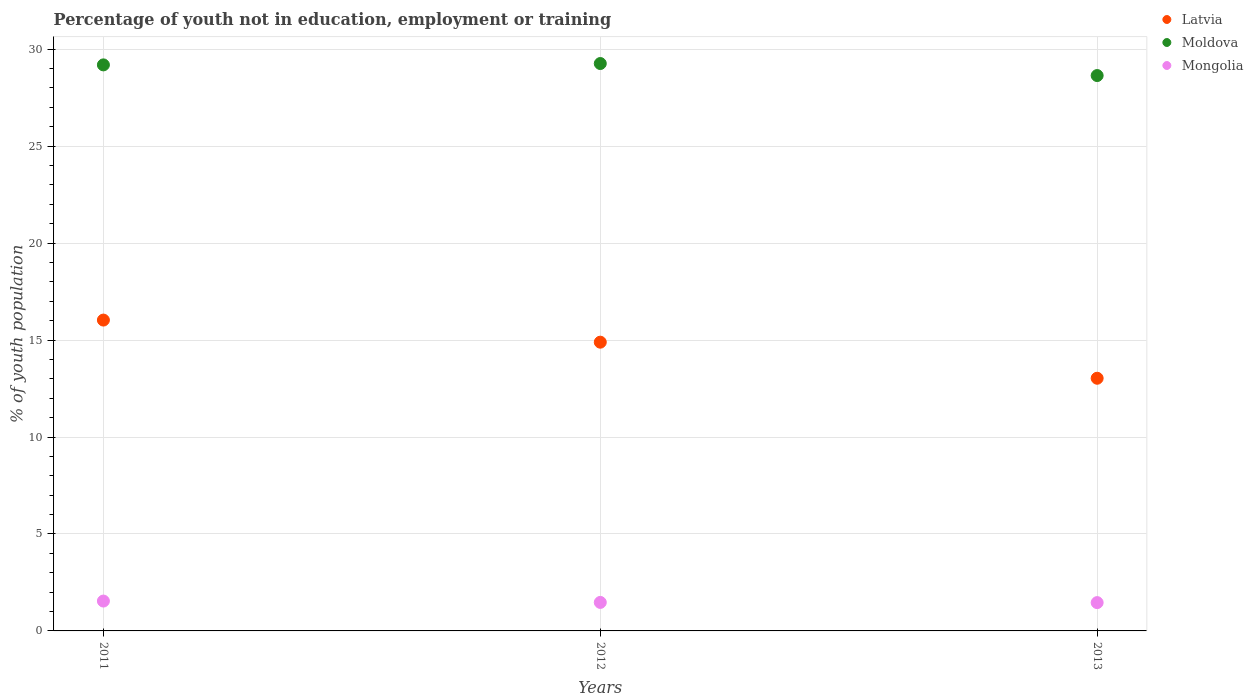How many different coloured dotlines are there?
Make the answer very short. 3. Is the number of dotlines equal to the number of legend labels?
Offer a terse response. Yes. What is the percentage of unemployed youth population in in Moldova in 2013?
Provide a succinct answer. 28.64. Across all years, what is the maximum percentage of unemployed youth population in in Latvia?
Offer a very short reply. 16.03. Across all years, what is the minimum percentage of unemployed youth population in in Mongolia?
Provide a short and direct response. 1.46. In which year was the percentage of unemployed youth population in in Latvia minimum?
Your answer should be very brief. 2013. What is the total percentage of unemployed youth population in in Latvia in the graph?
Your answer should be very brief. 43.95. What is the difference between the percentage of unemployed youth population in in Latvia in 2011 and that in 2013?
Your answer should be very brief. 3. What is the difference between the percentage of unemployed youth population in in Mongolia in 2013 and the percentage of unemployed youth population in in Moldova in 2012?
Your answer should be compact. -27.8. What is the average percentage of unemployed youth population in in Mongolia per year?
Your answer should be compact. 1.49. In the year 2012, what is the difference between the percentage of unemployed youth population in in Latvia and percentage of unemployed youth population in in Mongolia?
Provide a short and direct response. 13.42. What is the ratio of the percentage of unemployed youth population in in Latvia in 2011 to that in 2012?
Your answer should be compact. 1.08. Is the percentage of unemployed youth population in in Mongolia in 2011 less than that in 2013?
Ensure brevity in your answer.  No. What is the difference between the highest and the second highest percentage of unemployed youth population in in Latvia?
Provide a succinct answer. 1.14. What is the difference between the highest and the lowest percentage of unemployed youth population in in Latvia?
Make the answer very short. 3. Does the percentage of unemployed youth population in in Mongolia monotonically increase over the years?
Give a very brief answer. No. Is the percentage of unemployed youth population in in Latvia strictly greater than the percentage of unemployed youth population in in Mongolia over the years?
Offer a terse response. Yes. Is the percentage of unemployed youth population in in Mongolia strictly less than the percentage of unemployed youth population in in Moldova over the years?
Ensure brevity in your answer.  Yes. What is the difference between two consecutive major ticks on the Y-axis?
Keep it short and to the point. 5. Are the values on the major ticks of Y-axis written in scientific E-notation?
Your response must be concise. No. Does the graph contain any zero values?
Keep it short and to the point. No. Where does the legend appear in the graph?
Offer a terse response. Top right. What is the title of the graph?
Make the answer very short. Percentage of youth not in education, employment or training. Does "New Zealand" appear as one of the legend labels in the graph?
Ensure brevity in your answer.  No. What is the label or title of the Y-axis?
Give a very brief answer. % of youth population. What is the % of youth population of Latvia in 2011?
Ensure brevity in your answer.  16.03. What is the % of youth population in Moldova in 2011?
Ensure brevity in your answer.  29.19. What is the % of youth population in Mongolia in 2011?
Your answer should be compact. 1.54. What is the % of youth population in Latvia in 2012?
Your answer should be very brief. 14.89. What is the % of youth population of Moldova in 2012?
Keep it short and to the point. 29.26. What is the % of youth population of Mongolia in 2012?
Your response must be concise. 1.47. What is the % of youth population in Latvia in 2013?
Your answer should be very brief. 13.03. What is the % of youth population in Moldova in 2013?
Offer a terse response. 28.64. What is the % of youth population in Mongolia in 2013?
Ensure brevity in your answer.  1.46. Across all years, what is the maximum % of youth population of Latvia?
Make the answer very short. 16.03. Across all years, what is the maximum % of youth population in Moldova?
Offer a very short reply. 29.26. Across all years, what is the maximum % of youth population of Mongolia?
Give a very brief answer. 1.54. Across all years, what is the minimum % of youth population in Latvia?
Offer a very short reply. 13.03. Across all years, what is the minimum % of youth population in Moldova?
Offer a terse response. 28.64. Across all years, what is the minimum % of youth population of Mongolia?
Your answer should be compact. 1.46. What is the total % of youth population in Latvia in the graph?
Ensure brevity in your answer.  43.95. What is the total % of youth population in Moldova in the graph?
Ensure brevity in your answer.  87.09. What is the total % of youth population in Mongolia in the graph?
Your response must be concise. 4.47. What is the difference between the % of youth population in Latvia in 2011 and that in 2012?
Your answer should be very brief. 1.14. What is the difference between the % of youth population of Moldova in 2011 and that in 2012?
Provide a short and direct response. -0.07. What is the difference between the % of youth population of Mongolia in 2011 and that in 2012?
Offer a terse response. 0.07. What is the difference between the % of youth population of Latvia in 2011 and that in 2013?
Your answer should be very brief. 3. What is the difference between the % of youth population of Moldova in 2011 and that in 2013?
Provide a short and direct response. 0.55. What is the difference between the % of youth population of Mongolia in 2011 and that in 2013?
Keep it short and to the point. 0.08. What is the difference between the % of youth population of Latvia in 2012 and that in 2013?
Your answer should be compact. 1.86. What is the difference between the % of youth population of Moldova in 2012 and that in 2013?
Offer a terse response. 0.62. What is the difference between the % of youth population in Latvia in 2011 and the % of youth population in Moldova in 2012?
Give a very brief answer. -13.23. What is the difference between the % of youth population of Latvia in 2011 and the % of youth population of Mongolia in 2012?
Offer a very short reply. 14.56. What is the difference between the % of youth population in Moldova in 2011 and the % of youth population in Mongolia in 2012?
Keep it short and to the point. 27.72. What is the difference between the % of youth population of Latvia in 2011 and the % of youth population of Moldova in 2013?
Ensure brevity in your answer.  -12.61. What is the difference between the % of youth population in Latvia in 2011 and the % of youth population in Mongolia in 2013?
Your answer should be compact. 14.57. What is the difference between the % of youth population of Moldova in 2011 and the % of youth population of Mongolia in 2013?
Keep it short and to the point. 27.73. What is the difference between the % of youth population of Latvia in 2012 and the % of youth population of Moldova in 2013?
Provide a short and direct response. -13.75. What is the difference between the % of youth population of Latvia in 2012 and the % of youth population of Mongolia in 2013?
Give a very brief answer. 13.43. What is the difference between the % of youth population in Moldova in 2012 and the % of youth population in Mongolia in 2013?
Offer a very short reply. 27.8. What is the average % of youth population of Latvia per year?
Offer a very short reply. 14.65. What is the average % of youth population of Moldova per year?
Your answer should be compact. 29.03. What is the average % of youth population of Mongolia per year?
Make the answer very short. 1.49. In the year 2011, what is the difference between the % of youth population of Latvia and % of youth population of Moldova?
Make the answer very short. -13.16. In the year 2011, what is the difference between the % of youth population of Latvia and % of youth population of Mongolia?
Ensure brevity in your answer.  14.49. In the year 2011, what is the difference between the % of youth population of Moldova and % of youth population of Mongolia?
Provide a short and direct response. 27.65. In the year 2012, what is the difference between the % of youth population of Latvia and % of youth population of Moldova?
Ensure brevity in your answer.  -14.37. In the year 2012, what is the difference between the % of youth population in Latvia and % of youth population in Mongolia?
Offer a very short reply. 13.42. In the year 2012, what is the difference between the % of youth population in Moldova and % of youth population in Mongolia?
Provide a short and direct response. 27.79. In the year 2013, what is the difference between the % of youth population in Latvia and % of youth population in Moldova?
Ensure brevity in your answer.  -15.61. In the year 2013, what is the difference between the % of youth population in Latvia and % of youth population in Mongolia?
Give a very brief answer. 11.57. In the year 2013, what is the difference between the % of youth population in Moldova and % of youth population in Mongolia?
Give a very brief answer. 27.18. What is the ratio of the % of youth population of Latvia in 2011 to that in 2012?
Your response must be concise. 1.08. What is the ratio of the % of youth population of Moldova in 2011 to that in 2012?
Make the answer very short. 1. What is the ratio of the % of youth population of Mongolia in 2011 to that in 2012?
Give a very brief answer. 1.05. What is the ratio of the % of youth population of Latvia in 2011 to that in 2013?
Your answer should be very brief. 1.23. What is the ratio of the % of youth population in Moldova in 2011 to that in 2013?
Your answer should be very brief. 1.02. What is the ratio of the % of youth population in Mongolia in 2011 to that in 2013?
Offer a very short reply. 1.05. What is the ratio of the % of youth population in Latvia in 2012 to that in 2013?
Offer a very short reply. 1.14. What is the ratio of the % of youth population in Moldova in 2012 to that in 2013?
Provide a succinct answer. 1.02. What is the ratio of the % of youth population in Mongolia in 2012 to that in 2013?
Your response must be concise. 1.01. What is the difference between the highest and the second highest % of youth population in Latvia?
Give a very brief answer. 1.14. What is the difference between the highest and the second highest % of youth population in Moldova?
Offer a very short reply. 0.07. What is the difference between the highest and the second highest % of youth population in Mongolia?
Your answer should be compact. 0.07. What is the difference between the highest and the lowest % of youth population in Moldova?
Ensure brevity in your answer.  0.62. What is the difference between the highest and the lowest % of youth population in Mongolia?
Your answer should be compact. 0.08. 